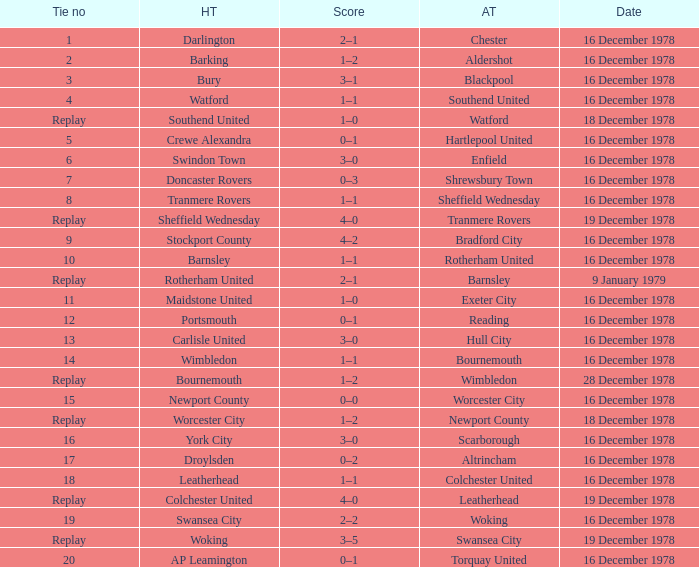What is the score for the date of 16 december 1978, with a tie no of 9? 4–2. 